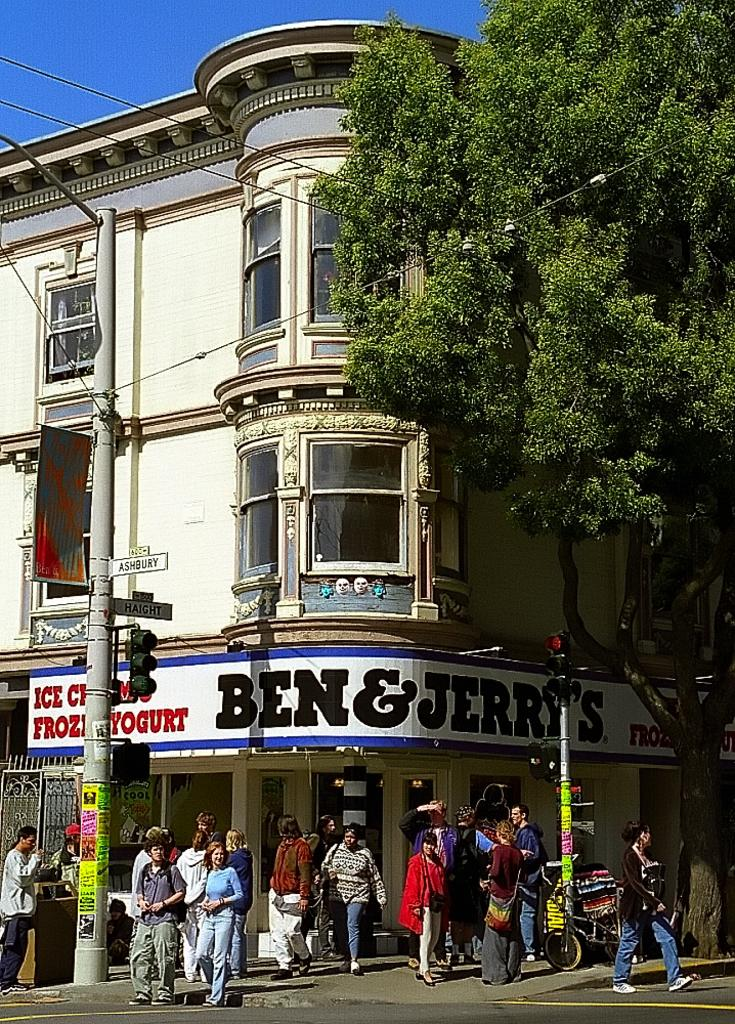<image>
Present a compact description of the photo's key features. People outside of a store which says Ben & Jerrys. 